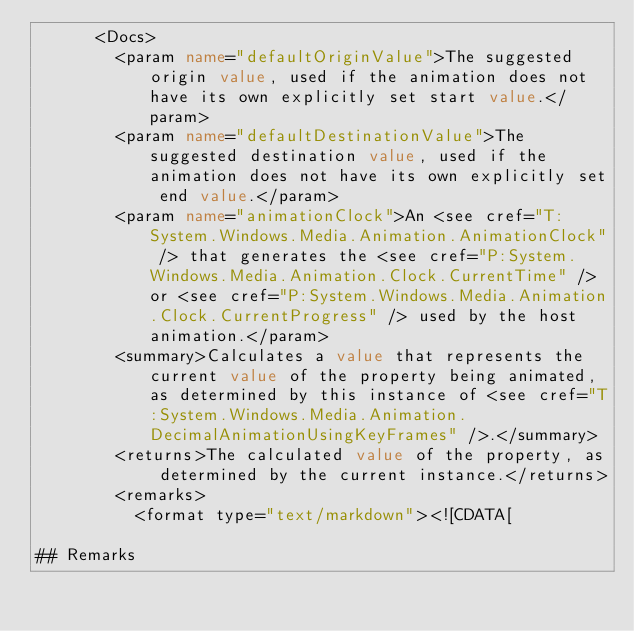Convert code to text. <code><loc_0><loc_0><loc_500><loc_500><_XML_>      <Docs>
        <param name="defaultOriginValue">The suggested origin value, used if the animation does not have its own explicitly set start value.</param>
        <param name="defaultDestinationValue">The suggested destination value, used if the animation does not have its own explicitly set end value.</param>
        <param name="animationClock">An <see cref="T:System.Windows.Media.Animation.AnimationClock" /> that generates the <see cref="P:System.Windows.Media.Animation.Clock.CurrentTime" /> or <see cref="P:System.Windows.Media.Animation.Clock.CurrentProgress" /> used by the host animation.</param>
        <summary>Calculates a value that represents the current value of the property being animated, as determined by this instance of <see cref="T:System.Windows.Media.Animation.DecimalAnimationUsingKeyFrames" />.</summary>
        <returns>The calculated value of the property, as determined by the current instance.</returns>
        <remarks>
          <format type="text/markdown"><![CDATA[  
  
## Remarks  </code> 